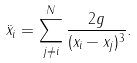<formula> <loc_0><loc_0><loc_500><loc_500>\ddot { x } _ { i } = \sum _ { j \neq i } ^ { N } \frac { 2 g } { ( x _ { i } - x _ { j } ) ^ { 3 } } .</formula> 